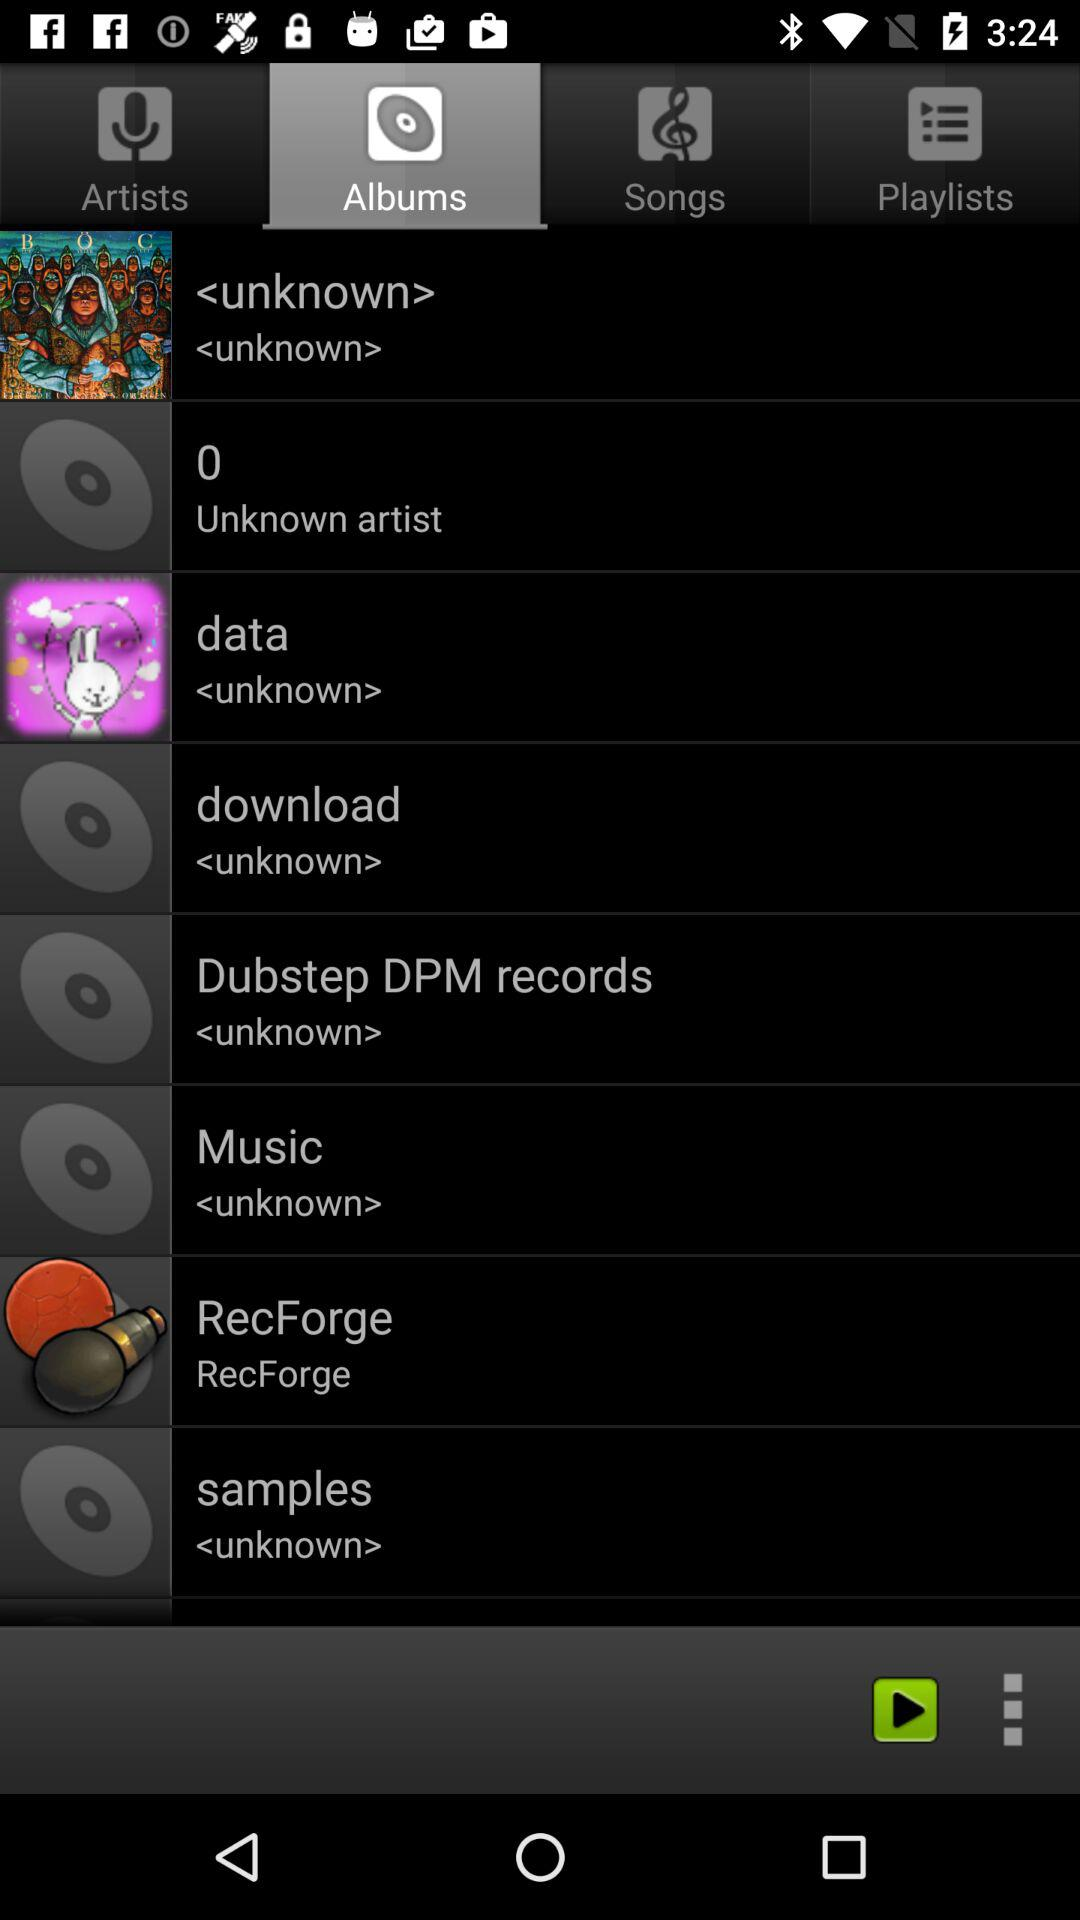Who's the singer of "data" album? The singer is unknown. 